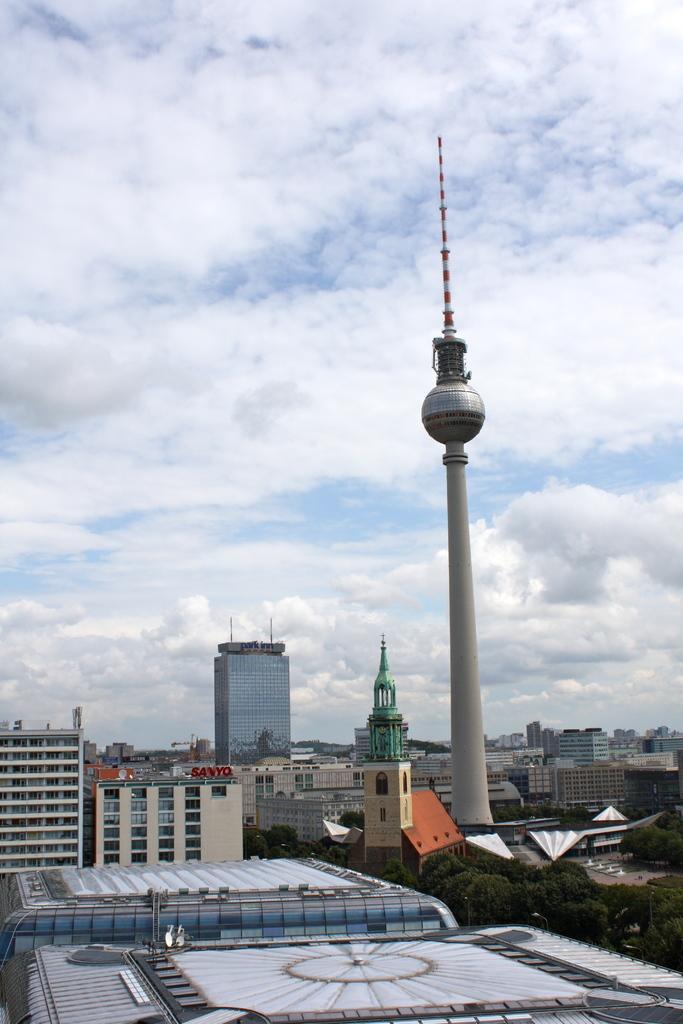Could you give a brief overview of what you see in this image? In the picture we can see some buildings and tower buildings and we can also see a pole construction and behind it also we can see full of buildings and sky with clouds. 